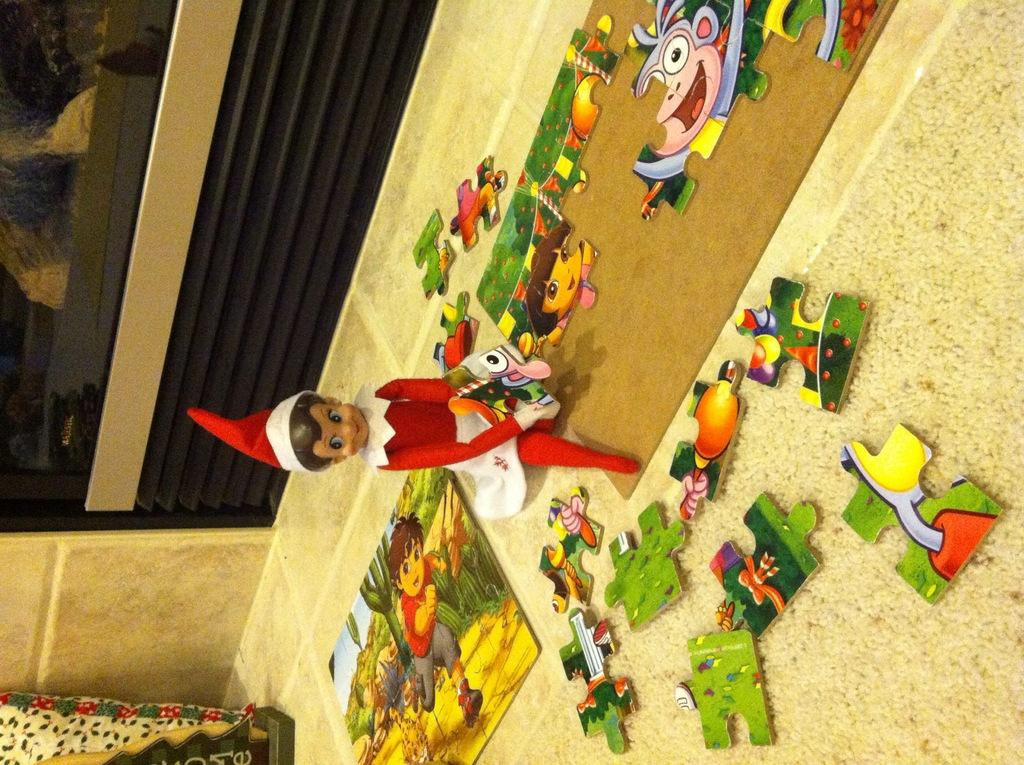What type of object can be seen in the image? There is a toy in the image. What other items are present in the image? There are puzzles in the image. What is on the floor in the image? There is a carpet on the floor in the image. What can be seen in the background of the image? There is a wall visible in the background of the image. What type of cheese is being used as a puzzle piece in the image? There is no cheese present in the image, and the puzzles do not involve any food items. 